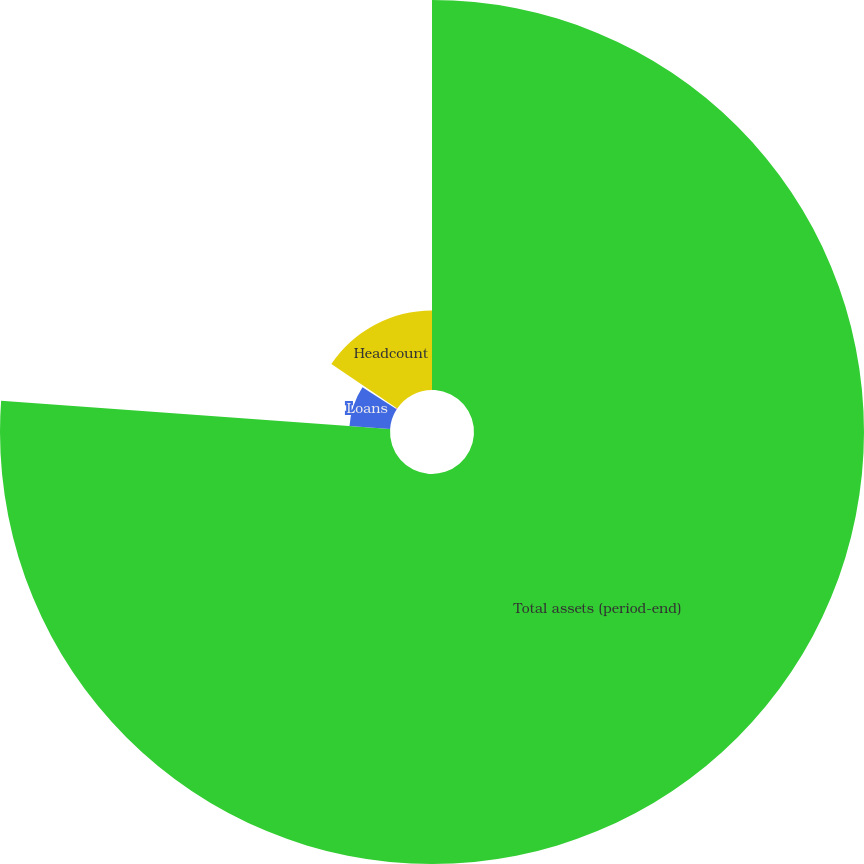Convert chart. <chart><loc_0><loc_0><loc_500><loc_500><pie_chart><fcel>Total assets (period-end)<fcel>Loans<fcel>Core loans (d)<fcel>Headcount<nl><fcel>76.15%<fcel>7.95%<fcel>0.37%<fcel>15.53%<nl></chart> 